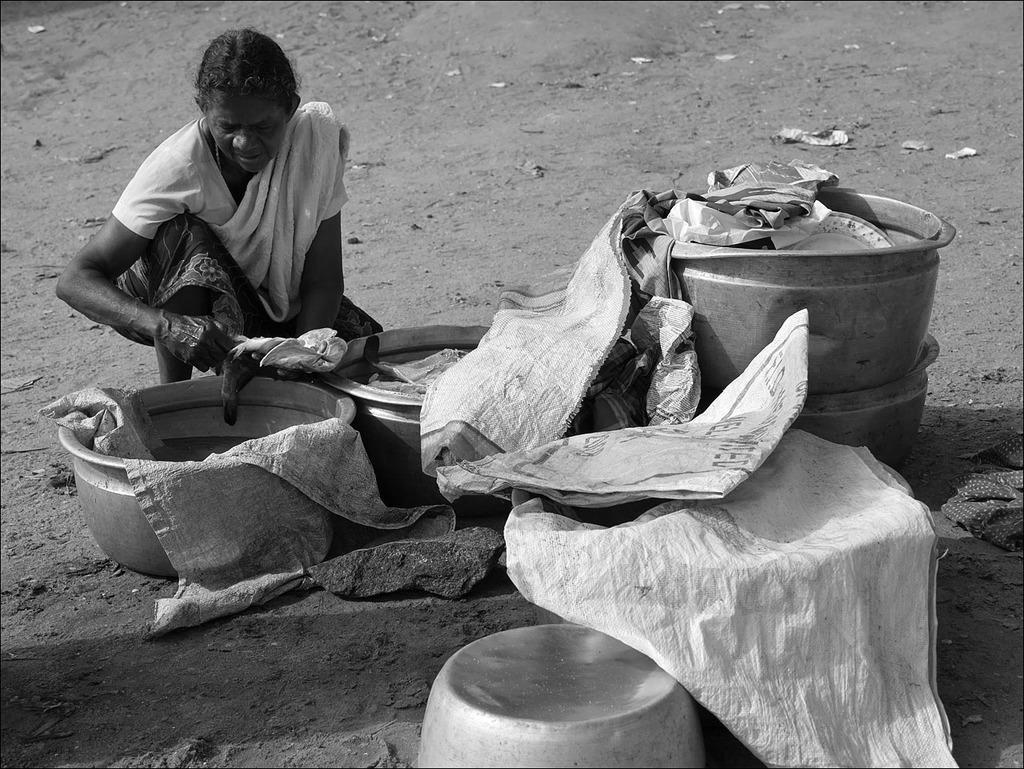Can you describe this image briefly? This image looks like black and white. In this image there is a woman sitting on the ground, in front of her there are some dishes covered with bag. 